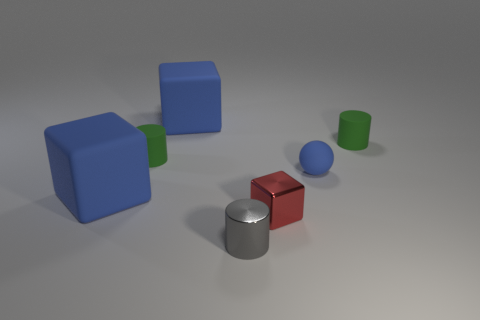Subtract all red cylinders. How many blue blocks are left? 2 Subtract all green matte cylinders. How many cylinders are left? 1 Add 3 metallic blocks. How many objects exist? 10 Subtract 1 cylinders. How many cylinders are left? 2 Subtract all balls. How many objects are left? 6 Add 5 shiny cylinders. How many shiny cylinders are left? 6 Add 4 blue things. How many blue things exist? 7 Subtract 0 purple cylinders. How many objects are left? 7 Subtract all gray blocks. Subtract all gray balls. How many blocks are left? 3 Subtract all big cubes. Subtract all rubber things. How many objects are left? 0 